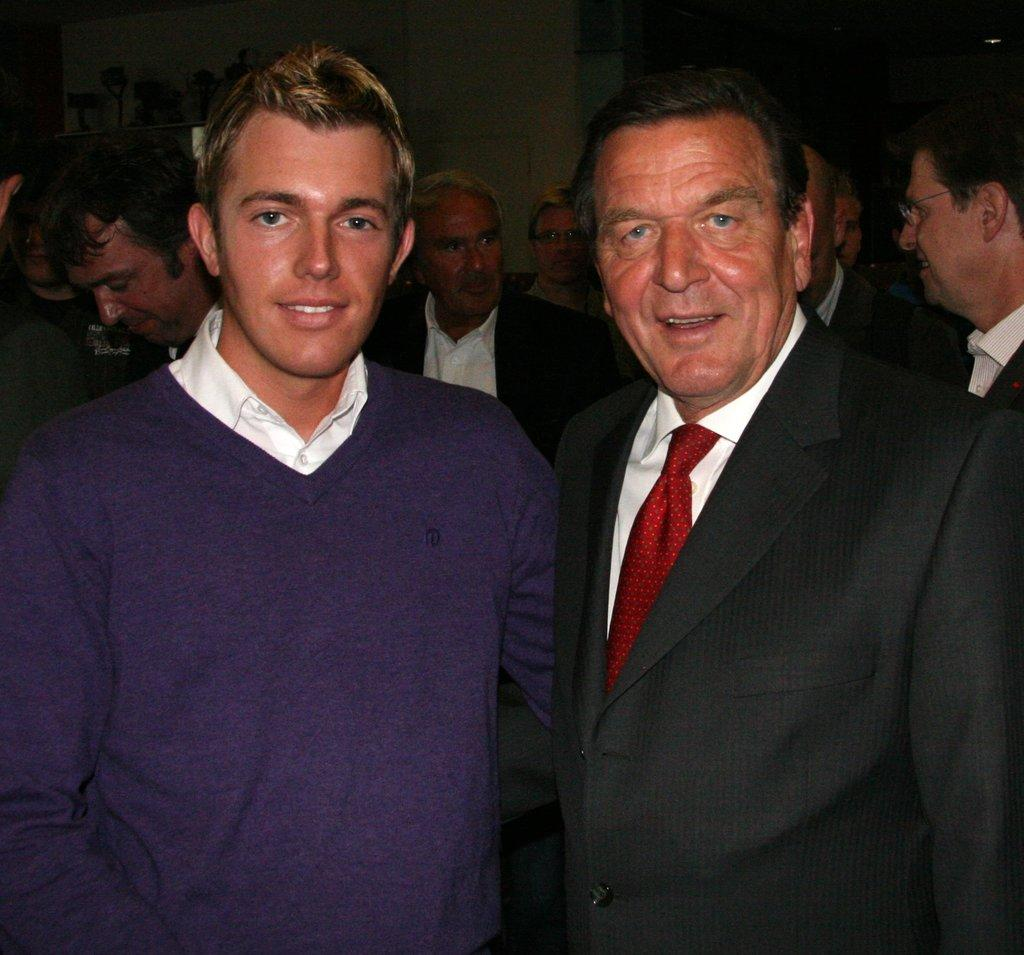How many people are in the image? There is a group of people in the image. What are the people doing in the image? The people are standing. What can be seen in the background of the image? There is a wall in the background of the image. What type of truck is parked next to the wall in the image? There is no truck present in the image; it only features a group of people standing and a wall in the background. 